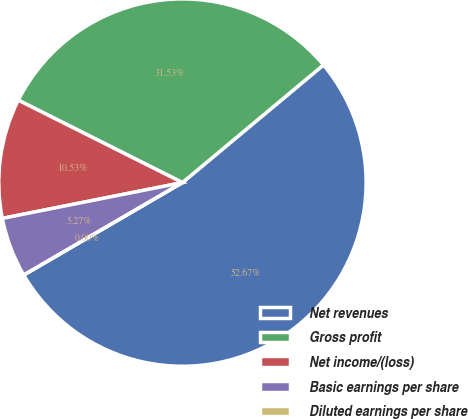Convert chart. <chart><loc_0><loc_0><loc_500><loc_500><pie_chart><fcel>Net revenues<fcel>Gross profit<fcel>Net income/(loss)<fcel>Basic earnings per share<fcel>Diluted earnings per share<nl><fcel>52.67%<fcel>31.53%<fcel>10.53%<fcel>5.27%<fcel>0.0%<nl></chart> 